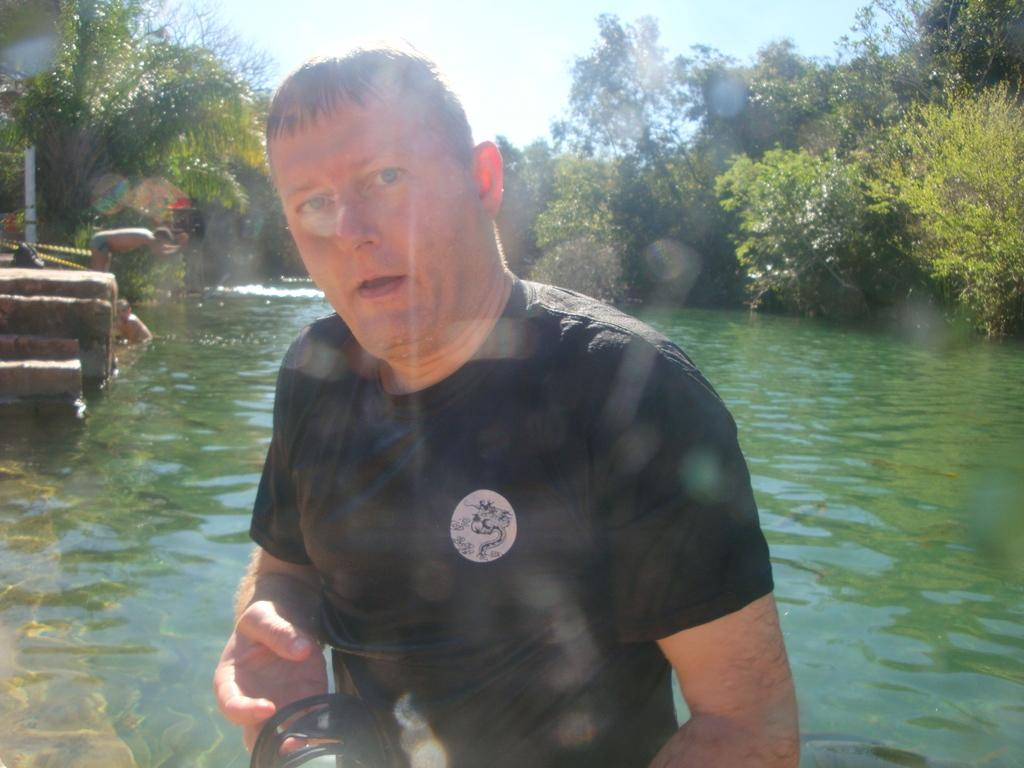What is the person in the foreground of the image wearing? The person in the foreground of the image is wearing a black t-shirt. What can be seen in the background of the image? In the background of the image, there is water, a person in the water, a person diving, trees, and the sky. How many people are visible in the water in the background of the image? There is one person visible in the water in the background of the image. What is the person in the background of the image doing? The person in the background of the image is diving. How long does it take for the tiger to swim across the water in the image? There is no tiger present in the image, so it is not possible to determine how long it would take for a tiger to swim across the water. 